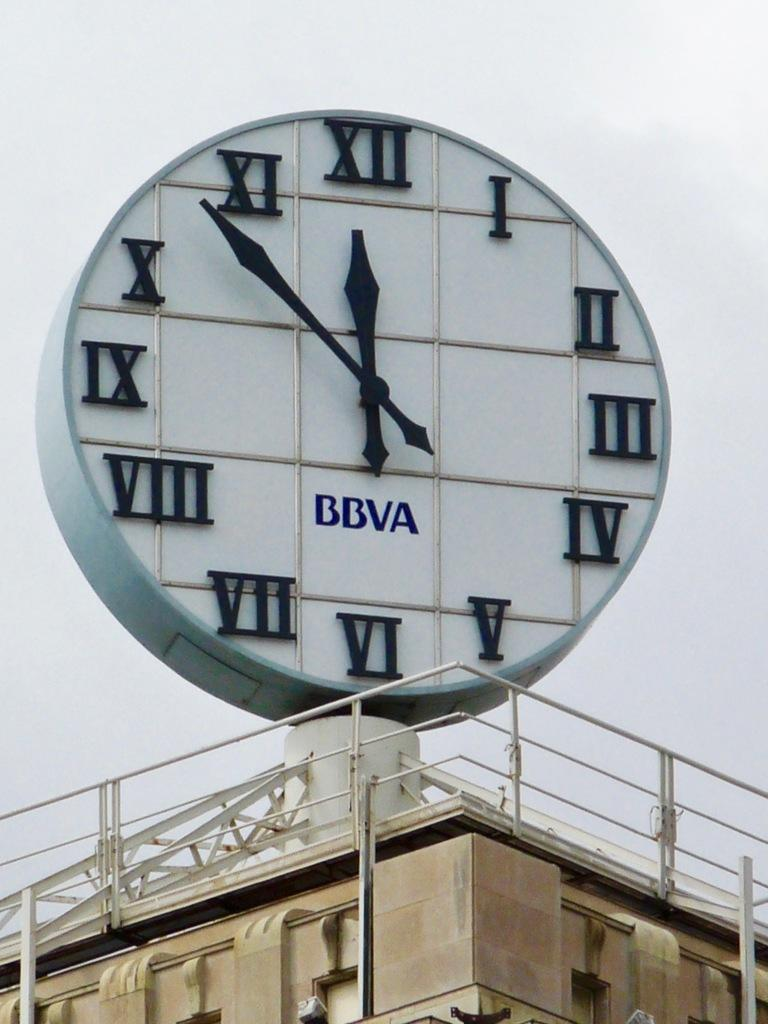<image>
Write a terse but informative summary of the picture. a huge clock at the top of a building that says 11:53 